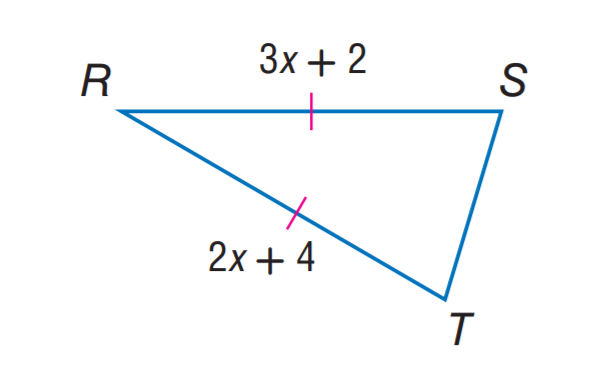Question: Find x.
Choices:
A. 2
B. 3
C. 4
D. 8
Answer with the letter. Answer: A Question: Find R T.
Choices:
A. 4
B. 6
C. 8
D. 10
Answer with the letter. Answer: C Question: Find R S.
Choices:
A. 4
B. 6
C. 8
D. 10
Answer with the letter. Answer: C 